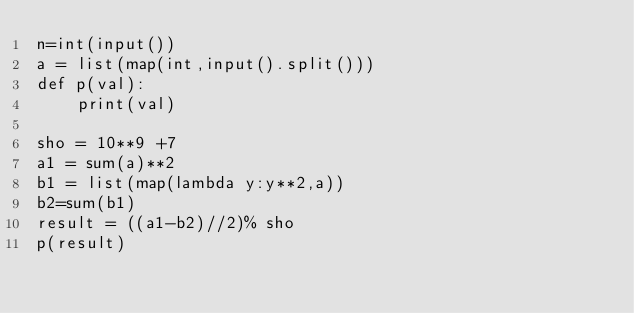<code> <loc_0><loc_0><loc_500><loc_500><_Python_>n=int(input())
a = list(map(int,input().split()))
def p(val):
    print(val)
 
sho = 10**9 +7
a1 = sum(a)**2
b1 = list(map(lambda y:y**2,a))
b2=sum(b1)
result = ((a1-b2)//2)% sho
p(result)</code> 